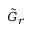Convert formula to latex. <formula><loc_0><loc_0><loc_500><loc_500>\tilde { G } _ { r }</formula> 